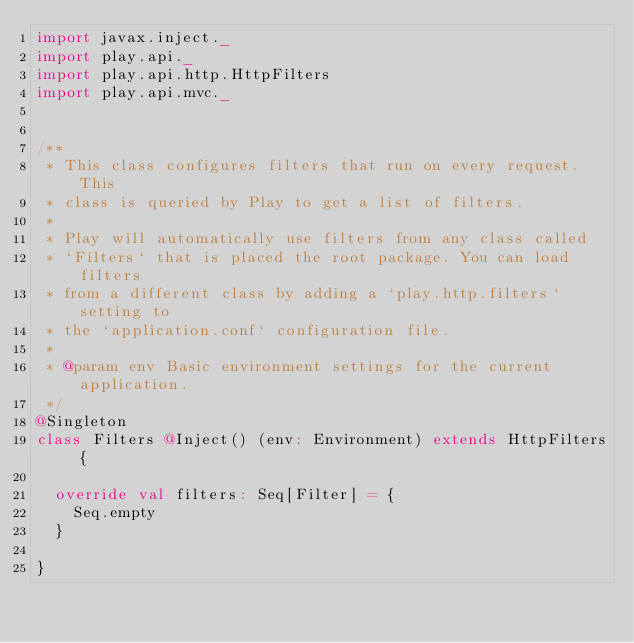<code> <loc_0><loc_0><loc_500><loc_500><_Scala_>import javax.inject._
import play.api._
import play.api.http.HttpFilters
import play.api.mvc._


/**
 * This class configures filters that run on every request. This
 * class is queried by Play to get a list of filters.
 *
 * Play will automatically use filters from any class called
 * `Filters` that is placed the root package. You can load filters
 * from a different class by adding a `play.http.filters` setting to
 * the `application.conf` configuration file.
 *
 * @param env Basic environment settings for the current application.
 */
@Singleton
class Filters @Inject() (env: Environment) extends HttpFilters {

  override val filters: Seq[Filter] = {
    Seq.empty
  }

}
</code> 